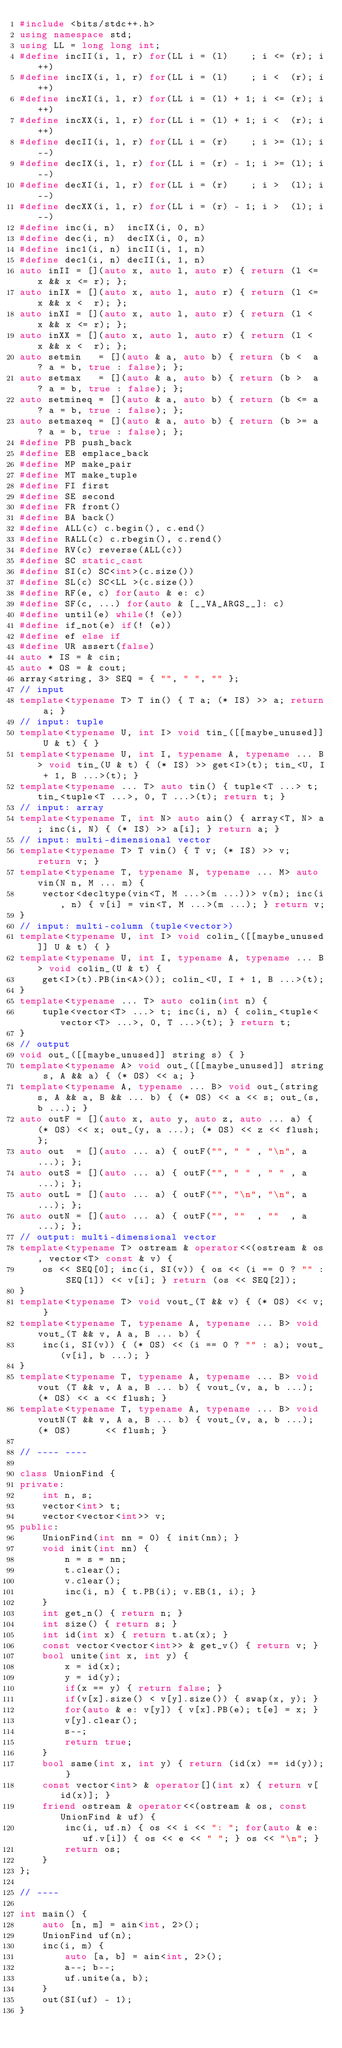<code> <loc_0><loc_0><loc_500><loc_500><_C++_>#include <bits/stdc++.h>
using namespace std;
using LL = long long int;
#define incII(i, l, r) for(LL i = (l)    ; i <= (r); i++)
#define incIX(i, l, r) for(LL i = (l)    ; i <  (r); i++)
#define incXI(i, l, r) for(LL i = (l) + 1; i <= (r); i++)
#define incXX(i, l, r) for(LL i = (l) + 1; i <  (r); i++)
#define decII(i, l, r) for(LL i = (r)    ; i >= (l); i--)
#define decIX(i, l, r) for(LL i = (r) - 1; i >= (l); i--)
#define decXI(i, l, r) for(LL i = (r)    ; i >  (l); i--)
#define decXX(i, l, r) for(LL i = (r) - 1; i >  (l); i--)
#define inc(i, n)  incIX(i, 0, n)
#define dec(i, n)  decIX(i, 0, n)
#define inc1(i, n) incII(i, 1, n)
#define dec1(i, n) decII(i, 1, n)
auto inII = [](auto x, auto l, auto r) { return (l <= x && x <= r); };
auto inIX = [](auto x, auto l, auto r) { return (l <= x && x <  r); };
auto inXI = [](auto x, auto l, auto r) { return (l <  x && x <= r); };
auto inXX = [](auto x, auto l, auto r) { return (l <  x && x <  r); };
auto setmin   = [](auto & a, auto b) { return (b <  a ? a = b, true : false); };
auto setmax   = [](auto & a, auto b) { return (b >  a ? a = b, true : false); };
auto setmineq = [](auto & a, auto b) { return (b <= a ? a = b, true : false); };
auto setmaxeq = [](auto & a, auto b) { return (b >= a ? a = b, true : false); };
#define PB push_back
#define EB emplace_back
#define MP make_pair
#define MT make_tuple
#define FI first
#define SE second
#define FR front()
#define BA back()
#define ALL(c) c.begin(), c.end()
#define RALL(c) c.rbegin(), c.rend()
#define RV(c) reverse(ALL(c))
#define SC static_cast
#define SI(c) SC<int>(c.size())
#define SL(c) SC<LL >(c.size())
#define RF(e, c) for(auto & e: c)
#define SF(c, ...) for(auto & [__VA_ARGS__]: c)
#define until(e) while(! (e))
#define if_not(e) if(! (e))
#define ef else if
#define UR assert(false)
auto * IS = & cin;
auto * OS = & cout;
array<string, 3> SEQ = { "", " ", "" };
// input
template<typename T> T in() { T a; (* IS) >> a; return a; }
// input: tuple
template<typename U, int I> void tin_([[maybe_unused]] U & t) { }
template<typename U, int I, typename A, typename ... B> void tin_(U & t) { (* IS) >> get<I>(t); tin_<U, I + 1, B ...>(t); }
template<typename ... T> auto tin() { tuple<T ...> t; tin_<tuple<T ...>, 0, T ...>(t); return t; }
// input: array
template<typename T, int N> auto ain() { array<T, N> a; inc(i, N) { (* IS) >> a[i]; } return a; }
// input: multi-dimensional vector
template<typename T> T vin() { T v; (* IS) >> v; return v; }
template<typename T, typename N, typename ... M> auto vin(N n, M ... m) {
	vector<decltype(vin<T, M ...>(m ...))> v(n); inc(i, n) { v[i] = vin<T, M ...>(m ...); } return v;
}
// input: multi-column (tuple<vector>)
template<typename U, int I> void colin_([[maybe_unused]] U & t) { }
template<typename U, int I, typename A, typename ... B> void colin_(U & t) {
	get<I>(t).PB(in<A>()); colin_<U, I + 1, B ...>(t);
}
template<typename ... T> auto colin(int n) {
	tuple<vector<T> ...> t; inc(i, n) { colin_<tuple<vector<T> ...>, 0, T ...>(t); } return t;
}
// output
void out_([[maybe_unused]] string s) { }
template<typename A> void out_([[maybe_unused]] string s, A && a) { (* OS) << a; }
template<typename A, typename ... B> void out_(string s, A && a, B && ... b) { (* OS) << a << s; out_(s, b ...); }
auto outF = [](auto x, auto y, auto z, auto ... a) { (* OS) << x; out_(y, a ...); (* OS) << z << flush; };
auto out  = [](auto ... a) { outF("", " " , "\n", a ...); };
auto outS = [](auto ... a) { outF("", " " , " " , a ...); };
auto outL = [](auto ... a) { outF("", "\n", "\n", a ...); };
auto outN = [](auto ... a) { outF("", ""  , ""  , a ...); };
// output: multi-dimensional vector
template<typename T> ostream & operator<<(ostream & os, vector<T> const & v) {
	os << SEQ[0]; inc(i, SI(v)) { os << (i == 0 ? "" : SEQ[1]) << v[i]; } return (os << SEQ[2]);
}
template<typename T> void vout_(T && v) { (* OS) << v; }
template<typename T, typename A, typename ... B> void vout_(T && v, A a, B ... b) {
	inc(i, SI(v)) { (* OS) << (i == 0 ? "" : a); vout_(v[i], b ...); }
}
template<typename T, typename A, typename ... B> void vout (T && v, A a, B ... b) { vout_(v, a, b ...); (* OS) << a << flush; }
template<typename T, typename A, typename ... B> void voutN(T && v, A a, B ... b) { vout_(v, a, b ...); (* OS)      << flush; }

// ---- ----

class UnionFind {
private:
	int n, s;
	vector<int> t;
	vector<vector<int>> v;
public:
	UnionFind(int nn = 0) { init(nn); }
	void init(int nn) {
		n = s = nn;
		t.clear();
		v.clear();
		inc(i, n) { t.PB(i); v.EB(1, i); }
	}
	int get_n() { return n; }
	int size() { return s; }
	int id(int x) { return t.at(x); }
	const vector<vector<int>> & get_v() { return v; }
	bool unite(int x, int y) {
		x = id(x);
		y = id(y);
		if(x == y) { return false; }
		if(v[x].size() < v[y].size()) { swap(x, y); }
		for(auto & e: v[y]) { v[x].PB(e); t[e] = x; }
		v[y].clear();
		s--;
		return true;
	}
	bool same(int x, int y) { return (id(x) == id(y)); }
	const vector<int> & operator[](int x) { return v[id(x)]; }
	friend ostream & operator<<(ostream & os, const UnionFind & uf) {
		inc(i, uf.n) { os << i << ": "; for(auto & e: uf.v[i]) { os << e << " "; } os << "\n"; }
		return os;
	}
};

// ----

int main() {
	auto [n, m] = ain<int, 2>();
	UnionFind uf(n);
	inc(i, m) {
		auto [a, b] = ain<int, 2>();
		a--; b--;
		uf.unite(a, b);
	}
	out(SI(uf) - 1);
}
</code> 